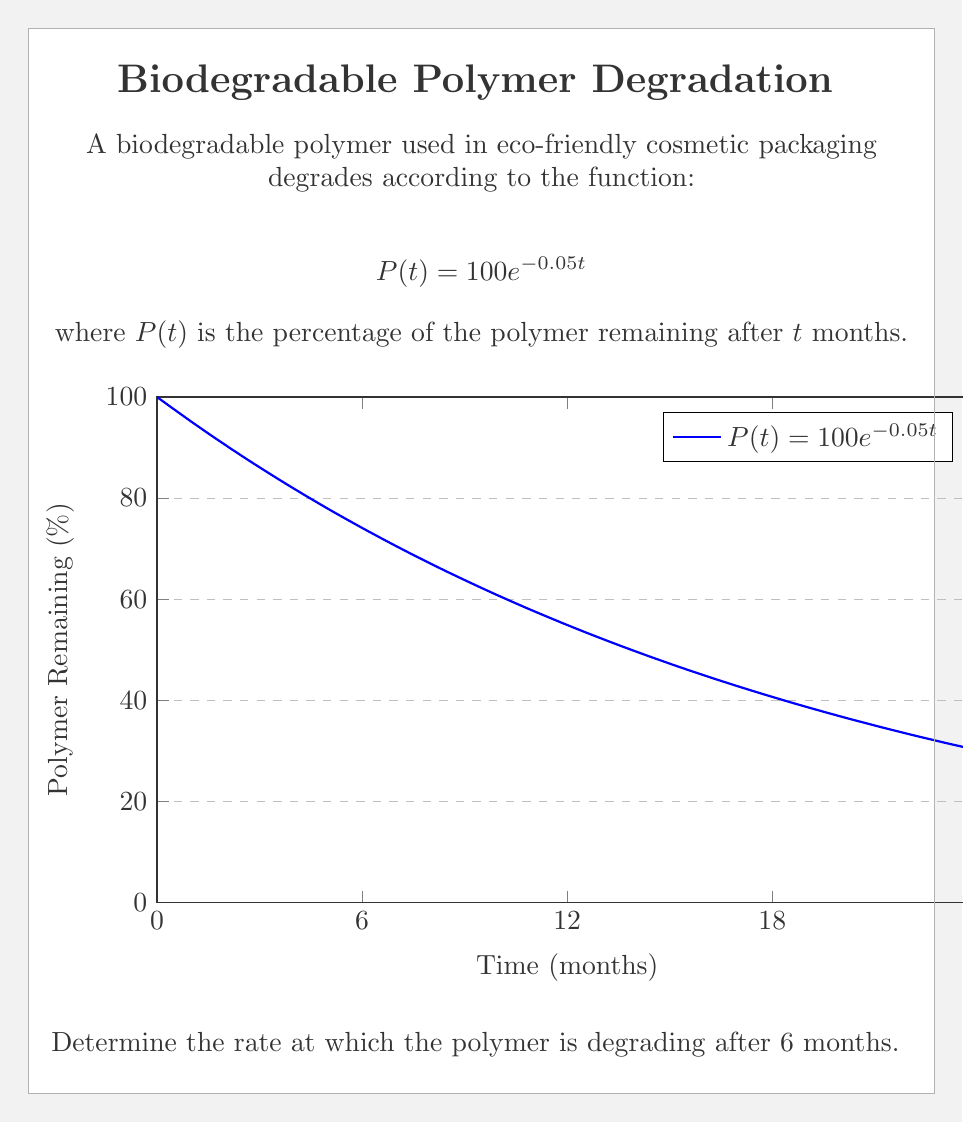What is the answer to this math problem? To find the rate of degradation at 6 months, we need to calculate the derivative of $P(t)$ and evaluate it at $t=6$. This will give us the instantaneous rate of change.

Step 1: Calculate the derivative of $P(t)$
$$\frac{d}{dt}P(t) = \frac{d}{dt}(100e^{-0.05t})$$
Using the chain rule:
$$\frac{d}{dt}P(t) = 100 \cdot (-0.05) \cdot e^{-0.05t}$$
$$\frac{d}{dt}P(t) = -5e^{-0.05t}$$

Step 2: Evaluate the derivative at $t=6$
$$\frac{d}{dt}P(6) = -5e^{-0.05(6)}$$
$$\frac{d}{dt}P(6) = -5e^{-0.3}$$
$$\frac{d}{dt}P(6) \approx -3.7042$$

Step 3: Interpret the result
The negative value indicates that the polymer is decreasing. The rate of degradation is approximately 3.7042% per month at 6 months.
Answer: $-3.7042\%$ per month 